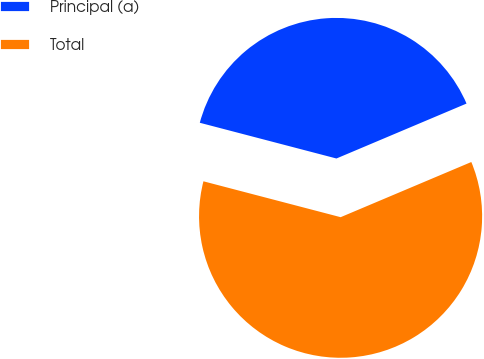<chart> <loc_0><loc_0><loc_500><loc_500><pie_chart><fcel>Principal (a)<fcel>Total<nl><fcel>39.57%<fcel>60.43%<nl></chart> 